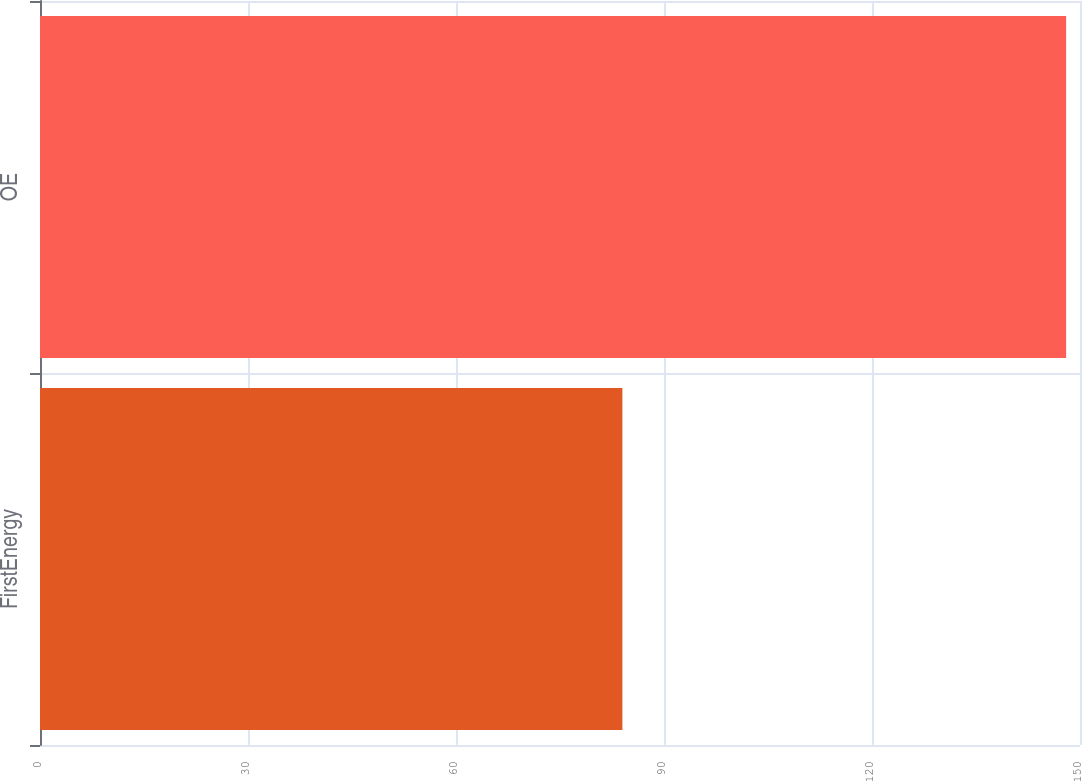<chart> <loc_0><loc_0><loc_500><loc_500><bar_chart><fcel>FirstEnergy<fcel>OE<nl><fcel>84<fcel>148<nl></chart> 